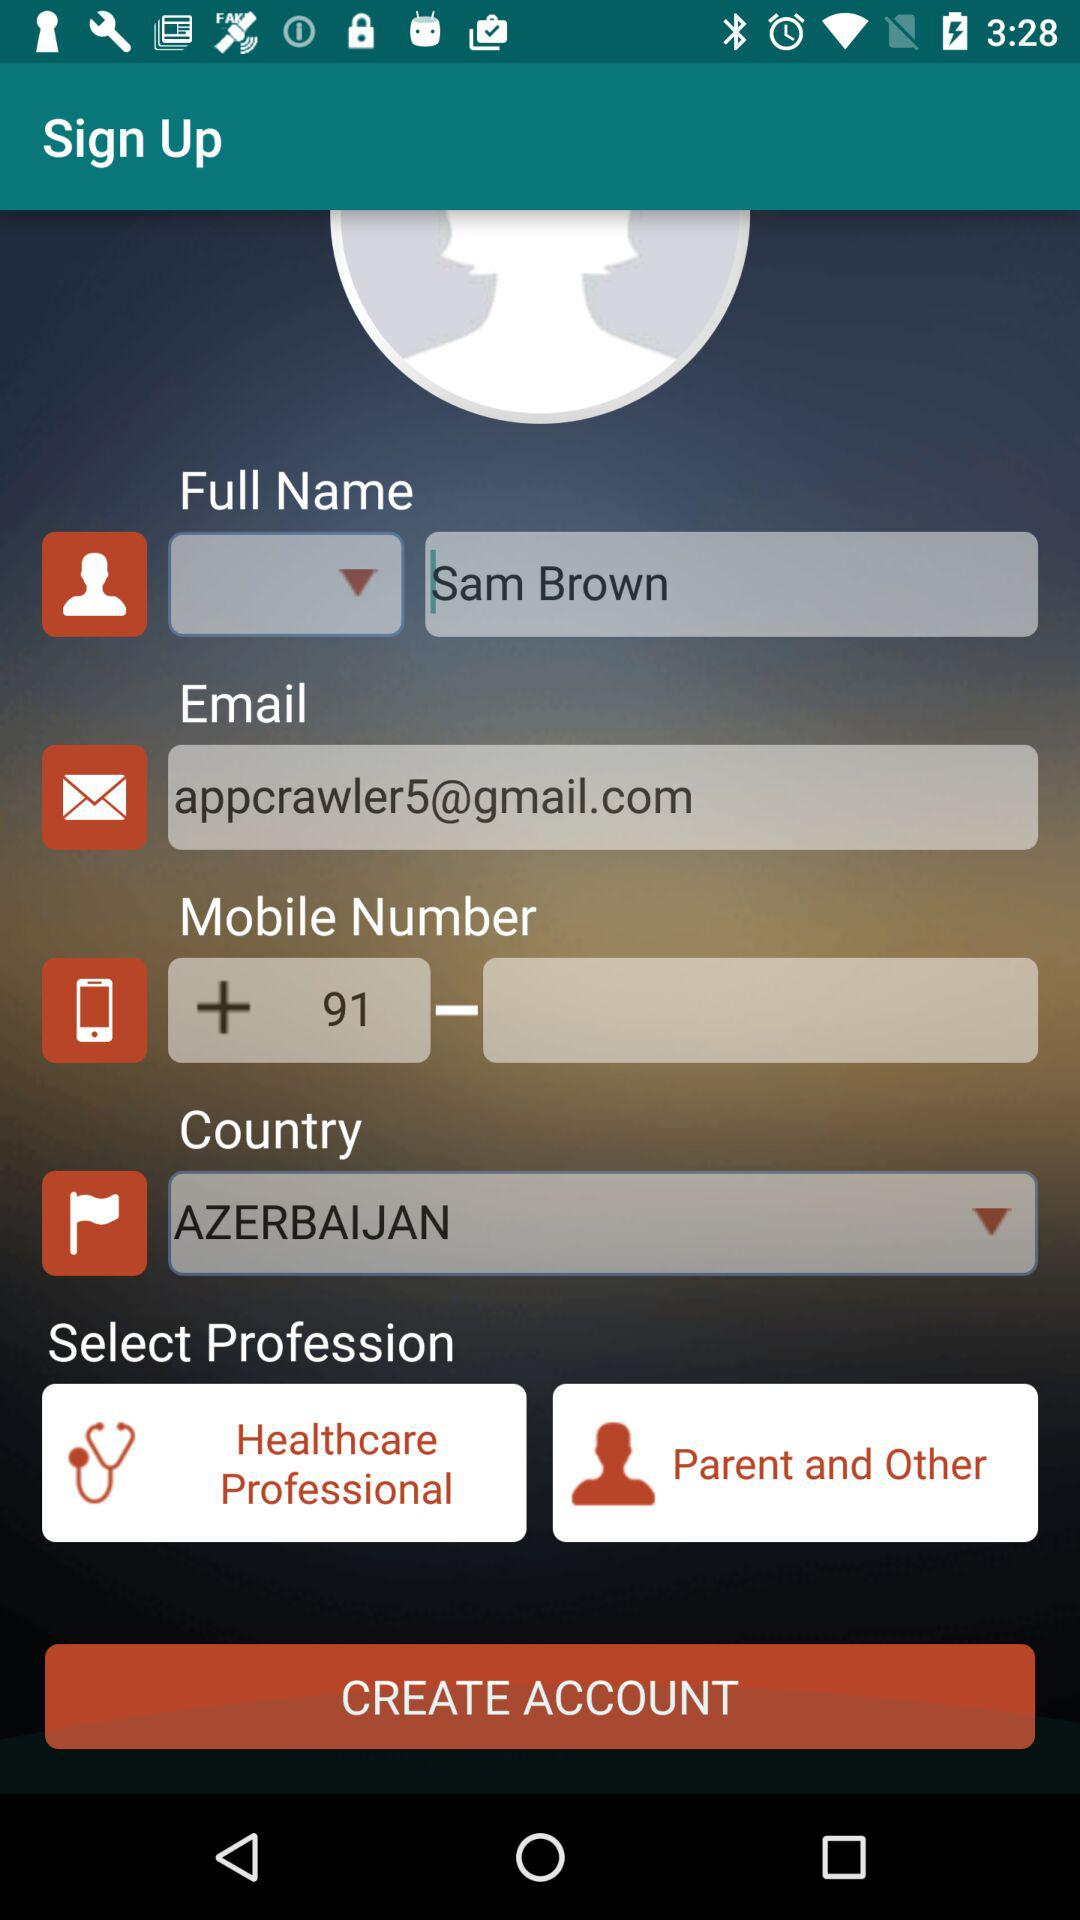What is the email address? The email address is appcrawler5@gmail.com. 